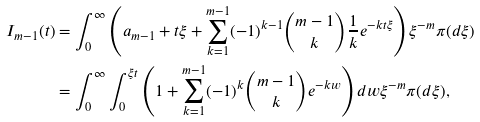<formula> <loc_0><loc_0><loc_500><loc_500>I _ { m - 1 } ( t ) & = \int _ { 0 } ^ { \infty } \left ( a _ { m - 1 } + t \xi + \sum _ { k = 1 } ^ { m - 1 } ( - 1 ) ^ { k - 1 } { m - 1 \choose k } \frac { 1 } { k } e ^ { - k t \xi } \right ) \xi ^ { - m } \pi ( d \xi ) \\ & = \int _ { 0 } ^ { \infty } \int _ { 0 } ^ { \xi t } \left ( 1 + \sum _ { k = 1 } ^ { m - 1 } ( - 1 ) ^ { k } { m - 1 \choose k } e ^ { - k w } \right ) d w \xi ^ { - m } \pi ( d \xi ) ,</formula> 